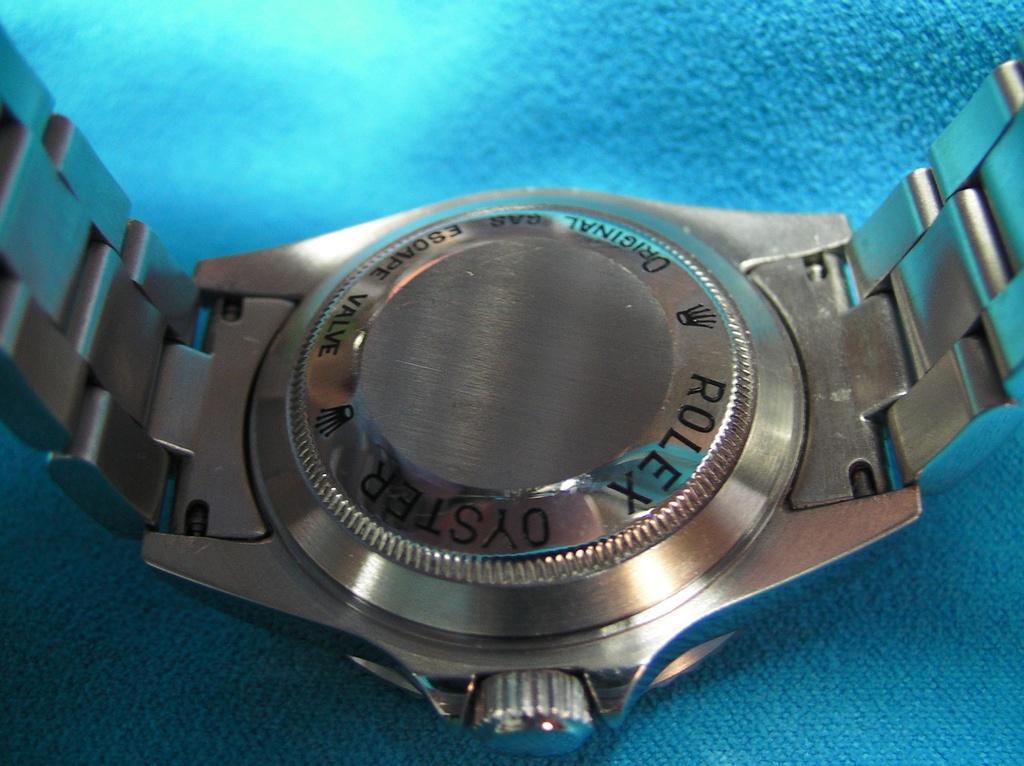Who makes the watch?
Provide a short and direct response. Rolex. Is this an original?
Offer a very short reply. Yes. 